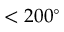Convert formula to latex. <formula><loc_0><loc_0><loc_500><loc_500>< 2 0 0 ^ { \circ }</formula> 